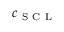<formula> <loc_0><loc_0><loc_500><loc_500>c _ { S C L }</formula> 